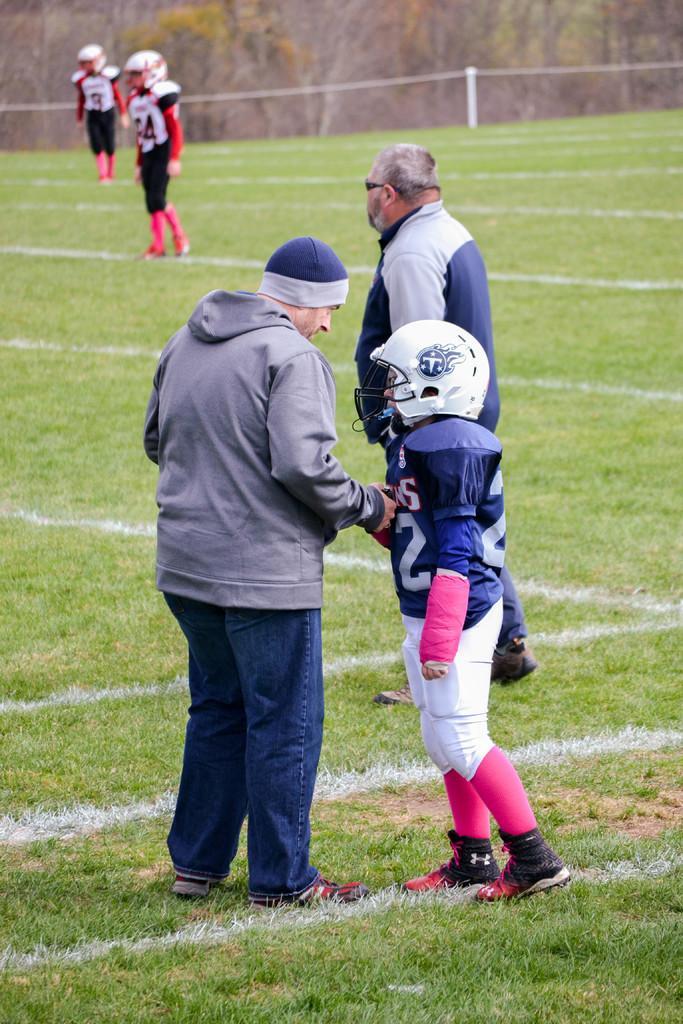In one or two sentences, can you explain what this image depicts? In this image we can see few people. Some are wearing helmets. One person is wearing cap. On the ground there is grass. In the background there are trees. 